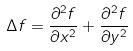Convert formula to latex. <formula><loc_0><loc_0><loc_500><loc_500>\Delta f = \frac { \partial ^ { 2 } f } { \partial x ^ { 2 } } + \frac { \partial ^ { 2 } f } { \partial y ^ { 2 } }</formula> 